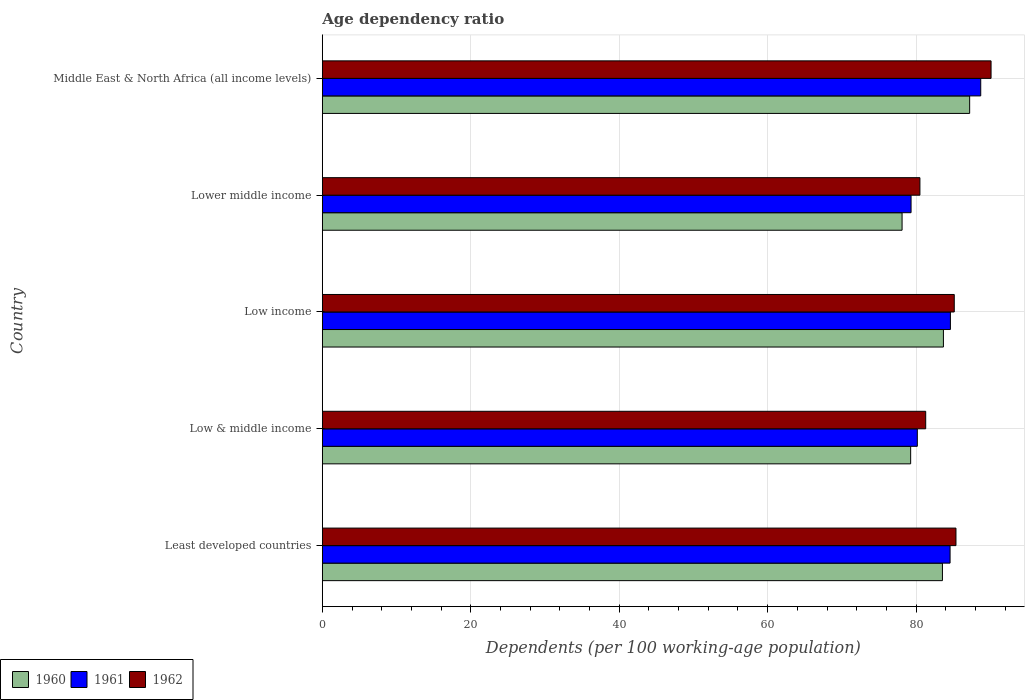How many groups of bars are there?
Keep it short and to the point. 5. Are the number of bars per tick equal to the number of legend labels?
Ensure brevity in your answer.  Yes. How many bars are there on the 5th tick from the top?
Provide a short and direct response. 3. What is the label of the 2nd group of bars from the top?
Provide a succinct answer. Lower middle income. What is the age dependency ratio in in 1960 in Lower middle income?
Make the answer very short. 78.11. Across all countries, what is the maximum age dependency ratio in in 1962?
Provide a short and direct response. 90.1. Across all countries, what is the minimum age dependency ratio in in 1962?
Your response must be concise. 80.51. In which country was the age dependency ratio in in 1961 maximum?
Provide a short and direct response. Middle East & North Africa (all income levels). In which country was the age dependency ratio in in 1961 minimum?
Offer a terse response. Lower middle income. What is the total age dependency ratio in in 1961 in the graph?
Your answer should be compact. 417.38. What is the difference between the age dependency ratio in in 1961 in Least developed countries and that in Low income?
Provide a succinct answer. -0.05. What is the difference between the age dependency ratio in in 1962 in Low & middle income and the age dependency ratio in in 1961 in Middle East & North Africa (all income levels)?
Your answer should be compact. -7.41. What is the average age dependency ratio in in 1961 per country?
Ensure brevity in your answer.  83.48. What is the difference between the age dependency ratio in in 1961 and age dependency ratio in in 1960 in Low income?
Your response must be concise. 0.94. In how many countries, is the age dependency ratio in in 1961 greater than 68 %?
Give a very brief answer. 5. What is the ratio of the age dependency ratio in in 1961 in Low & middle income to that in Low income?
Offer a very short reply. 0.95. Is the age dependency ratio in in 1962 in Low income less than that in Middle East & North Africa (all income levels)?
Offer a terse response. Yes. Is the difference between the age dependency ratio in in 1961 in Low & middle income and Low income greater than the difference between the age dependency ratio in in 1960 in Low & middle income and Low income?
Make the answer very short. No. What is the difference between the highest and the second highest age dependency ratio in in 1961?
Give a very brief answer. 4.08. What is the difference between the highest and the lowest age dependency ratio in in 1960?
Your response must be concise. 9.11. Is the sum of the age dependency ratio in in 1961 in Least developed countries and Low income greater than the maximum age dependency ratio in in 1960 across all countries?
Your answer should be compact. Yes. What does the 1st bar from the top in Least developed countries represents?
Keep it short and to the point. 1962. Is it the case that in every country, the sum of the age dependency ratio in in 1960 and age dependency ratio in in 1962 is greater than the age dependency ratio in in 1961?
Provide a short and direct response. Yes. How many bars are there?
Make the answer very short. 15. Are the values on the major ticks of X-axis written in scientific E-notation?
Offer a terse response. No. Does the graph contain any zero values?
Provide a short and direct response. No. Does the graph contain grids?
Ensure brevity in your answer.  Yes. Where does the legend appear in the graph?
Offer a very short reply. Bottom left. How are the legend labels stacked?
Keep it short and to the point. Horizontal. What is the title of the graph?
Ensure brevity in your answer.  Age dependency ratio. Does "1979" appear as one of the legend labels in the graph?
Your answer should be very brief. No. What is the label or title of the X-axis?
Ensure brevity in your answer.  Dependents (per 100 working-age population). What is the label or title of the Y-axis?
Ensure brevity in your answer.  Country. What is the Dependents (per 100 working-age population) of 1960 in Least developed countries?
Make the answer very short. 83.55. What is the Dependents (per 100 working-age population) of 1961 in Least developed countries?
Offer a terse response. 84.57. What is the Dependents (per 100 working-age population) of 1962 in Least developed countries?
Your response must be concise. 85.37. What is the Dependents (per 100 working-age population) of 1960 in Low & middle income?
Offer a very short reply. 79.26. What is the Dependents (per 100 working-age population) of 1961 in Low & middle income?
Offer a terse response. 80.16. What is the Dependents (per 100 working-age population) of 1962 in Low & middle income?
Provide a succinct answer. 81.29. What is the Dependents (per 100 working-age population) of 1960 in Low income?
Your answer should be very brief. 83.68. What is the Dependents (per 100 working-age population) of 1961 in Low income?
Your response must be concise. 84.62. What is the Dependents (per 100 working-age population) in 1962 in Low income?
Provide a short and direct response. 85.14. What is the Dependents (per 100 working-age population) of 1960 in Lower middle income?
Provide a succinct answer. 78.11. What is the Dependents (per 100 working-age population) in 1961 in Lower middle income?
Your response must be concise. 79.32. What is the Dependents (per 100 working-age population) of 1962 in Lower middle income?
Offer a terse response. 80.51. What is the Dependents (per 100 working-age population) of 1960 in Middle East & North Africa (all income levels)?
Your answer should be compact. 87.21. What is the Dependents (per 100 working-age population) in 1961 in Middle East & North Africa (all income levels)?
Your response must be concise. 88.7. What is the Dependents (per 100 working-age population) in 1962 in Middle East & North Africa (all income levels)?
Give a very brief answer. 90.1. Across all countries, what is the maximum Dependents (per 100 working-age population) in 1960?
Your response must be concise. 87.21. Across all countries, what is the maximum Dependents (per 100 working-age population) in 1961?
Give a very brief answer. 88.7. Across all countries, what is the maximum Dependents (per 100 working-age population) of 1962?
Make the answer very short. 90.1. Across all countries, what is the minimum Dependents (per 100 working-age population) in 1960?
Your response must be concise. 78.11. Across all countries, what is the minimum Dependents (per 100 working-age population) of 1961?
Provide a short and direct response. 79.32. Across all countries, what is the minimum Dependents (per 100 working-age population) in 1962?
Give a very brief answer. 80.51. What is the total Dependents (per 100 working-age population) of 1960 in the graph?
Ensure brevity in your answer.  411.81. What is the total Dependents (per 100 working-age population) of 1961 in the graph?
Provide a succinct answer. 417.38. What is the total Dependents (per 100 working-age population) in 1962 in the graph?
Your answer should be compact. 422.41. What is the difference between the Dependents (per 100 working-age population) of 1960 in Least developed countries and that in Low & middle income?
Offer a terse response. 4.28. What is the difference between the Dependents (per 100 working-age population) of 1961 in Least developed countries and that in Low & middle income?
Your answer should be compact. 4.41. What is the difference between the Dependents (per 100 working-age population) of 1962 in Least developed countries and that in Low & middle income?
Give a very brief answer. 4.08. What is the difference between the Dependents (per 100 working-age population) of 1960 in Least developed countries and that in Low income?
Your response must be concise. -0.13. What is the difference between the Dependents (per 100 working-age population) in 1961 in Least developed countries and that in Low income?
Offer a very short reply. -0.05. What is the difference between the Dependents (per 100 working-age population) of 1962 in Least developed countries and that in Low income?
Keep it short and to the point. 0.23. What is the difference between the Dependents (per 100 working-age population) of 1960 in Least developed countries and that in Lower middle income?
Your answer should be compact. 5.44. What is the difference between the Dependents (per 100 working-age population) of 1961 in Least developed countries and that in Lower middle income?
Give a very brief answer. 5.26. What is the difference between the Dependents (per 100 working-age population) in 1962 in Least developed countries and that in Lower middle income?
Provide a succinct answer. 4.86. What is the difference between the Dependents (per 100 working-age population) of 1960 in Least developed countries and that in Middle East & North Africa (all income levels)?
Your answer should be very brief. -3.67. What is the difference between the Dependents (per 100 working-age population) in 1961 in Least developed countries and that in Middle East & North Africa (all income levels)?
Keep it short and to the point. -4.13. What is the difference between the Dependents (per 100 working-age population) of 1962 in Least developed countries and that in Middle East & North Africa (all income levels)?
Your answer should be very brief. -4.73. What is the difference between the Dependents (per 100 working-age population) of 1960 in Low & middle income and that in Low income?
Give a very brief answer. -4.41. What is the difference between the Dependents (per 100 working-age population) in 1961 in Low & middle income and that in Low income?
Make the answer very short. -4.46. What is the difference between the Dependents (per 100 working-age population) in 1962 in Low & middle income and that in Low income?
Give a very brief answer. -3.85. What is the difference between the Dependents (per 100 working-age population) of 1960 in Low & middle income and that in Lower middle income?
Ensure brevity in your answer.  1.16. What is the difference between the Dependents (per 100 working-age population) of 1961 in Low & middle income and that in Lower middle income?
Provide a succinct answer. 0.84. What is the difference between the Dependents (per 100 working-age population) of 1962 in Low & middle income and that in Lower middle income?
Make the answer very short. 0.78. What is the difference between the Dependents (per 100 working-age population) in 1960 in Low & middle income and that in Middle East & North Africa (all income levels)?
Provide a short and direct response. -7.95. What is the difference between the Dependents (per 100 working-age population) of 1961 in Low & middle income and that in Middle East & North Africa (all income levels)?
Your answer should be compact. -8.54. What is the difference between the Dependents (per 100 working-age population) in 1962 in Low & middle income and that in Middle East & North Africa (all income levels)?
Make the answer very short. -8.8. What is the difference between the Dependents (per 100 working-age population) in 1960 in Low income and that in Lower middle income?
Your response must be concise. 5.57. What is the difference between the Dependents (per 100 working-age population) of 1961 in Low income and that in Lower middle income?
Your answer should be compact. 5.3. What is the difference between the Dependents (per 100 working-age population) of 1962 in Low income and that in Lower middle income?
Provide a short and direct response. 4.63. What is the difference between the Dependents (per 100 working-age population) of 1960 in Low income and that in Middle East & North Africa (all income levels)?
Provide a short and direct response. -3.54. What is the difference between the Dependents (per 100 working-age population) in 1961 in Low income and that in Middle East & North Africa (all income levels)?
Make the answer very short. -4.08. What is the difference between the Dependents (per 100 working-age population) in 1962 in Low income and that in Middle East & North Africa (all income levels)?
Your answer should be compact. -4.96. What is the difference between the Dependents (per 100 working-age population) in 1960 in Lower middle income and that in Middle East & North Africa (all income levels)?
Give a very brief answer. -9.11. What is the difference between the Dependents (per 100 working-age population) in 1961 in Lower middle income and that in Middle East & North Africa (all income levels)?
Your response must be concise. -9.39. What is the difference between the Dependents (per 100 working-age population) of 1962 in Lower middle income and that in Middle East & North Africa (all income levels)?
Give a very brief answer. -9.58. What is the difference between the Dependents (per 100 working-age population) of 1960 in Least developed countries and the Dependents (per 100 working-age population) of 1961 in Low & middle income?
Make the answer very short. 3.38. What is the difference between the Dependents (per 100 working-age population) in 1960 in Least developed countries and the Dependents (per 100 working-age population) in 1962 in Low & middle income?
Your response must be concise. 2.26. What is the difference between the Dependents (per 100 working-age population) in 1961 in Least developed countries and the Dependents (per 100 working-age population) in 1962 in Low & middle income?
Your response must be concise. 3.28. What is the difference between the Dependents (per 100 working-age population) in 1960 in Least developed countries and the Dependents (per 100 working-age population) in 1961 in Low income?
Your response must be concise. -1.07. What is the difference between the Dependents (per 100 working-age population) in 1960 in Least developed countries and the Dependents (per 100 working-age population) in 1962 in Low income?
Your answer should be very brief. -1.59. What is the difference between the Dependents (per 100 working-age population) of 1961 in Least developed countries and the Dependents (per 100 working-age population) of 1962 in Low income?
Your answer should be compact. -0.57. What is the difference between the Dependents (per 100 working-age population) in 1960 in Least developed countries and the Dependents (per 100 working-age population) in 1961 in Lower middle income?
Offer a terse response. 4.23. What is the difference between the Dependents (per 100 working-age population) of 1960 in Least developed countries and the Dependents (per 100 working-age population) of 1962 in Lower middle income?
Keep it short and to the point. 3.03. What is the difference between the Dependents (per 100 working-age population) of 1961 in Least developed countries and the Dependents (per 100 working-age population) of 1962 in Lower middle income?
Your answer should be very brief. 4.06. What is the difference between the Dependents (per 100 working-age population) in 1960 in Least developed countries and the Dependents (per 100 working-age population) in 1961 in Middle East & North Africa (all income levels)?
Your answer should be compact. -5.16. What is the difference between the Dependents (per 100 working-age population) of 1960 in Least developed countries and the Dependents (per 100 working-age population) of 1962 in Middle East & North Africa (all income levels)?
Offer a very short reply. -6.55. What is the difference between the Dependents (per 100 working-age population) in 1961 in Least developed countries and the Dependents (per 100 working-age population) in 1962 in Middle East & North Africa (all income levels)?
Your answer should be compact. -5.52. What is the difference between the Dependents (per 100 working-age population) of 1960 in Low & middle income and the Dependents (per 100 working-age population) of 1961 in Low income?
Your answer should be very brief. -5.36. What is the difference between the Dependents (per 100 working-age population) of 1960 in Low & middle income and the Dependents (per 100 working-age population) of 1962 in Low income?
Keep it short and to the point. -5.87. What is the difference between the Dependents (per 100 working-age population) of 1961 in Low & middle income and the Dependents (per 100 working-age population) of 1962 in Low income?
Make the answer very short. -4.98. What is the difference between the Dependents (per 100 working-age population) in 1960 in Low & middle income and the Dependents (per 100 working-age population) in 1961 in Lower middle income?
Make the answer very short. -0.05. What is the difference between the Dependents (per 100 working-age population) in 1960 in Low & middle income and the Dependents (per 100 working-age population) in 1962 in Lower middle income?
Your response must be concise. -1.25. What is the difference between the Dependents (per 100 working-age population) of 1961 in Low & middle income and the Dependents (per 100 working-age population) of 1962 in Lower middle income?
Your response must be concise. -0.35. What is the difference between the Dependents (per 100 working-age population) of 1960 in Low & middle income and the Dependents (per 100 working-age population) of 1961 in Middle East & North Africa (all income levels)?
Make the answer very short. -9.44. What is the difference between the Dependents (per 100 working-age population) in 1960 in Low & middle income and the Dependents (per 100 working-age population) in 1962 in Middle East & North Africa (all income levels)?
Your answer should be compact. -10.83. What is the difference between the Dependents (per 100 working-age population) of 1961 in Low & middle income and the Dependents (per 100 working-age population) of 1962 in Middle East & North Africa (all income levels)?
Give a very brief answer. -9.93. What is the difference between the Dependents (per 100 working-age population) of 1960 in Low income and the Dependents (per 100 working-age population) of 1961 in Lower middle income?
Make the answer very short. 4.36. What is the difference between the Dependents (per 100 working-age population) in 1960 in Low income and the Dependents (per 100 working-age population) in 1962 in Lower middle income?
Keep it short and to the point. 3.17. What is the difference between the Dependents (per 100 working-age population) in 1961 in Low income and the Dependents (per 100 working-age population) in 1962 in Lower middle income?
Give a very brief answer. 4.11. What is the difference between the Dependents (per 100 working-age population) of 1960 in Low income and the Dependents (per 100 working-age population) of 1961 in Middle East & North Africa (all income levels)?
Make the answer very short. -5.03. What is the difference between the Dependents (per 100 working-age population) of 1960 in Low income and the Dependents (per 100 working-age population) of 1962 in Middle East & North Africa (all income levels)?
Keep it short and to the point. -6.42. What is the difference between the Dependents (per 100 working-age population) in 1961 in Low income and the Dependents (per 100 working-age population) in 1962 in Middle East & North Africa (all income levels)?
Keep it short and to the point. -5.48. What is the difference between the Dependents (per 100 working-age population) in 1960 in Lower middle income and the Dependents (per 100 working-age population) in 1961 in Middle East & North Africa (all income levels)?
Your response must be concise. -10.6. What is the difference between the Dependents (per 100 working-age population) in 1960 in Lower middle income and the Dependents (per 100 working-age population) in 1962 in Middle East & North Africa (all income levels)?
Offer a terse response. -11.99. What is the difference between the Dependents (per 100 working-age population) in 1961 in Lower middle income and the Dependents (per 100 working-age population) in 1962 in Middle East & North Africa (all income levels)?
Provide a succinct answer. -10.78. What is the average Dependents (per 100 working-age population) in 1960 per country?
Your response must be concise. 82.36. What is the average Dependents (per 100 working-age population) of 1961 per country?
Keep it short and to the point. 83.48. What is the average Dependents (per 100 working-age population) of 1962 per country?
Make the answer very short. 84.48. What is the difference between the Dependents (per 100 working-age population) of 1960 and Dependents (per 100 working-age population) of 1961 in Least developed countries?
Your response must be concise. -1.03. What is the difference between the Dependents (per 100 working-age population) of 1960 and Dependents (per 100 working-age population) of 1962 in Least developed countries?
Ensure brevity in your answer.  -1.82. What is the difference between the Dependents (per 100 working-age population) of 1961 and Dependents (per 100 working-age population) of 1962 in Least developed countries?
Offer a very short reply. -0.8. What is the difference between the Dependents (per 100 working-age population) in 1960 and Dependents (per 100 working-age population) in 1961 in Low & middle income?
Give a very brief answer. -0.9. What is the difference between the Dependents (per 100 working-age population) of 1960 and Dependents (per 100 working-age population) of 1962 in Low & middle income?
Offer a terse response. -2.03. What is the difference between the Dependents (per 100 working-age population) in 1961 and Dependents (per 100 working-age population) in 1962 in Low & middle income?
Your answer should be very brief. -1.13. What is the difference between the Dependents (per 100 working-age population) of 1960 and Dependents (per 100 working-age population) of 1961 in Low income?
Offer a terse response. -0.94. What is the difference between the Dependents (per 100 working-age population) in 1960 and Dependents (per 100 working-age population) in 1962 in Low income?
Your answer should be very brief. -1.46. What is the difference between the Dependents (per 100 working-age population) of 1961 and Dependents (per 100 working-age population) of 1962 in Low income?
Give a very brief answer. -0.52. What is the difference between the Dependents (per 100 working-age population) in 1960 and Dependents (per 100 working-age population) in 1961 in Lower middle income?
Provide a short and direct response. -1.21. What is the difference between the Dependents (per 100 working-age population) in 1960 and Dependents (per 100 working-age population) in 1962 in Lower middle income?
Your response must be concise. -2.4. What is the difference between the Dependents (per 100 working-age population) in 1961 and Dependents (per 100 working-age population) in 1962 in Lower middle income?
Ensure brevity in your answer.  -1.19. What is the difference between the Dependents (per 100 working-age population) of 1960 and Dependents (per 100 working-age population) of 1961 in Middle East & North Africa (all income levels)?
Your answer should be compact. -1.49. What is the difference between the Dependents (per 100 working-age population) in 1960 and Dependents (per 100 working-age population) in 1962 in Middle East & North Africa (all income levels)?
Give a very brief answer. -2.88. What is the difference between the Dependents (per 100 working-age population) in 1961 and Dependents (per 100 working-age population) in 1962 in Middle East & North Africa (all income levels)?
Offer a very short reply. -1.39. What is the ratio of the Dependents (per 100 working-age population) in 1960 in Least developed countries to that in Low & middle income?
Provide a succinct answer. 1.05. What is the ratio of the Dependents (per 100 working-age population) in 1961 in Least developed countries to that in Low & middle income?
Keep it short and to the point. 1.05. What is the ratio of the Dependents (per 100 working-age population) of 1962 in Least developed countries to that in Low & middle income?
Provide a short and direct response. 1.05. What is the ratio of the Dependents (per 100 working-age population) in 1960 in Least developed countries to that in Low income?
Provide a short and direct response. 1. What is the ratio of the Dependents (per 100 working-age population) of 1962 in Least developed countries to that in Low income?
Your response must be concise. 1. What is the ratio of the Dependents (per 100 working-age population) of 1960 in Least developed countries to that in Lower middle income?
Offer a terse response. 1.07. What is the ratio of the Dependents (per 100 working-age population) of 1961 in Least developed countries to that in Lower middle income?
Give a very brief answer. 1.07. What is the ratio of the Dependents (per 100 working-age population) of 1962 in Least developed countries to that in Lower middle income?
Your answer should be very brief. 1.06. What is the ratio of the Dependents (per 100 working-age population) in 1960 in Least developed countries to that in Middle East & North Africa (all income levels)?
Your answer should be very brief. 0.96. What is the ratio of the Dependents (per 100 working-age population) in 1961 in Least developed countries to that in Middle East & North Africa (all income levels)?
Give a very brief answer. 0.95. What is the ratio of the Dependents (per 100 working-age population) of 1962 in Least developed countries to that in Middle East & North Africa (all income levels)?
Make the answer very short. 0.95. What is the ratio of the Dependents (per 100 working-age population) in 1960 in Low & middle income to that in Low income?
Ensure brevity in your answer.  0.95. What is the ratio of the Dependents (per 100 working-age population) in 1961 in Low & middle income to that in Low income?
Keep it short and to the point. 0.95. What is the ratio of the Dependents (per 100 working-age population) of 1962 in Low & middle income to that in Low income?
Give a very brief answer. 0.95. What is the ratio of the Dependents (per 100 working-age population) in 1960 in Low & middle income to that in Lower middle income?
Give a very brief answer. 1.01. What is the ratio of the Dependents (per 100 working-age population) of 1961 in Low & middle income to that in Lower middle income?
Make the answer very short. 1.01. What is the ratio of the Dependents (per 100 working-age population) of 1962 in Low & middle income to that in Lower middle income?
Provide a succinct answer. 1.01. What is the ratio of the Dependents (per 100 working-age population) of 1960 in Low & middle income to that in Middle East & North Africa (all income levels)?
Give a very brief answer. 0.91. What is the ratio of the Dependents (per 100 working-age population) in 1961 in Low & middle income to that in Middle East & North Africa (all income levels)?
Provide a short and direct response. 0.9. What is the ratio of the Dependents (per 100 working-age population) in 1962 in Low & middle income to that in Middle East & North Africa (all income levels)?
Ensure brevity in your answer.  0.9. What is the ratio of the Dependents (per 100 working-age population) of 1960 in Low income to that in Lower middle income?
Provide a succinct answer. 1.07. What is the ratio of the Dependents (per 100 working-age population) in 1961 in Low income to that in Lower middle income?
Offer a terse response. 1.07. What is the ratio of the Dependents (per 100 working-age population) in 1962 in Low income to that in Lower middle income?
Offer a very short reply. 1.06. What is the ratio of the Dependents (per 100 working-age population) of 1960 in Low income to that in Middle East & North Africa (all income levels)?
Your answer should be very brief. 0.96. What is the ratio of the Dependents (per 100 working-age population) of 1961 in Low income to that in Middle East & North Africa (all income levels)?
Your response must be concise. 0.95. What is the ratio of the Dependents (per 100 working-age population) of 1962 in Low income to that in Middle East & North Africa (all income levels)?
Your response must be concise. 0.94. What is the ratio of the Dependents (per 100 working-age population) of 1960 in Lower middle income to that in Middle East & North Africa (all income levels)?
Your response must be concise. 0.9. What is the ratio of the Dependents (per 100 working-age population) of 1961 in Lower middle income to that in Middle East & North Africa (all income levels)?
Make the answer very short. 0.89. What is the ratio of the Dependents (per 100 working-age population) of 1962 in Lower middle income to that in Middle East & North Africa (all income levels)?
Offer a terse response. 0.89. What is the difference between the highest and the second highest Dependents (per 100 working-age population) in 1960?
Keep it short and to the point. 3.54. What is the difference between the highest and the second highest Dependents (per 100 working-age population) in 1961?
Make the answer very short. 4.08. What is the difference between the highest and the second highest Dependents (per 100 working-age population) in 1962?
Give a very brief answer. 4.73. What is the difference between the highest and the lowest Dependents (per 100 working-age population) in 1960?
Offer a terse response. 9.11. What is the difference between the highest and the lowest Dependents (per 100 working-age population) in 1961?
Your response must be concise. 9.39. What is the difference between the highest and the lowest Dependents (per 100 working-age population) in 1962?
Offer a terse response. 9.58. 